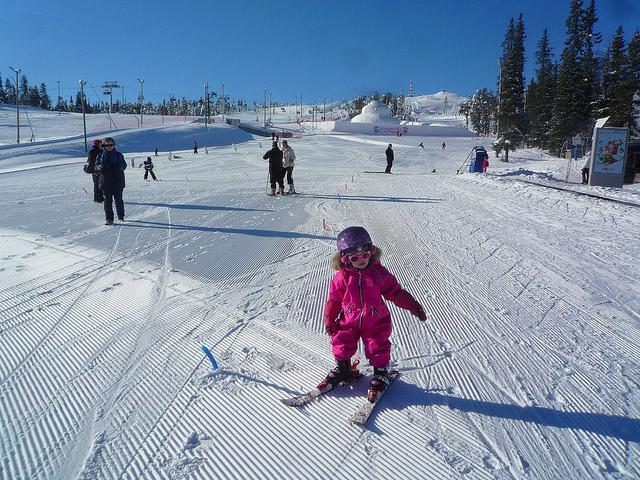How many people are standing to the left of the open train door?
Give a very brief answer. 0. 